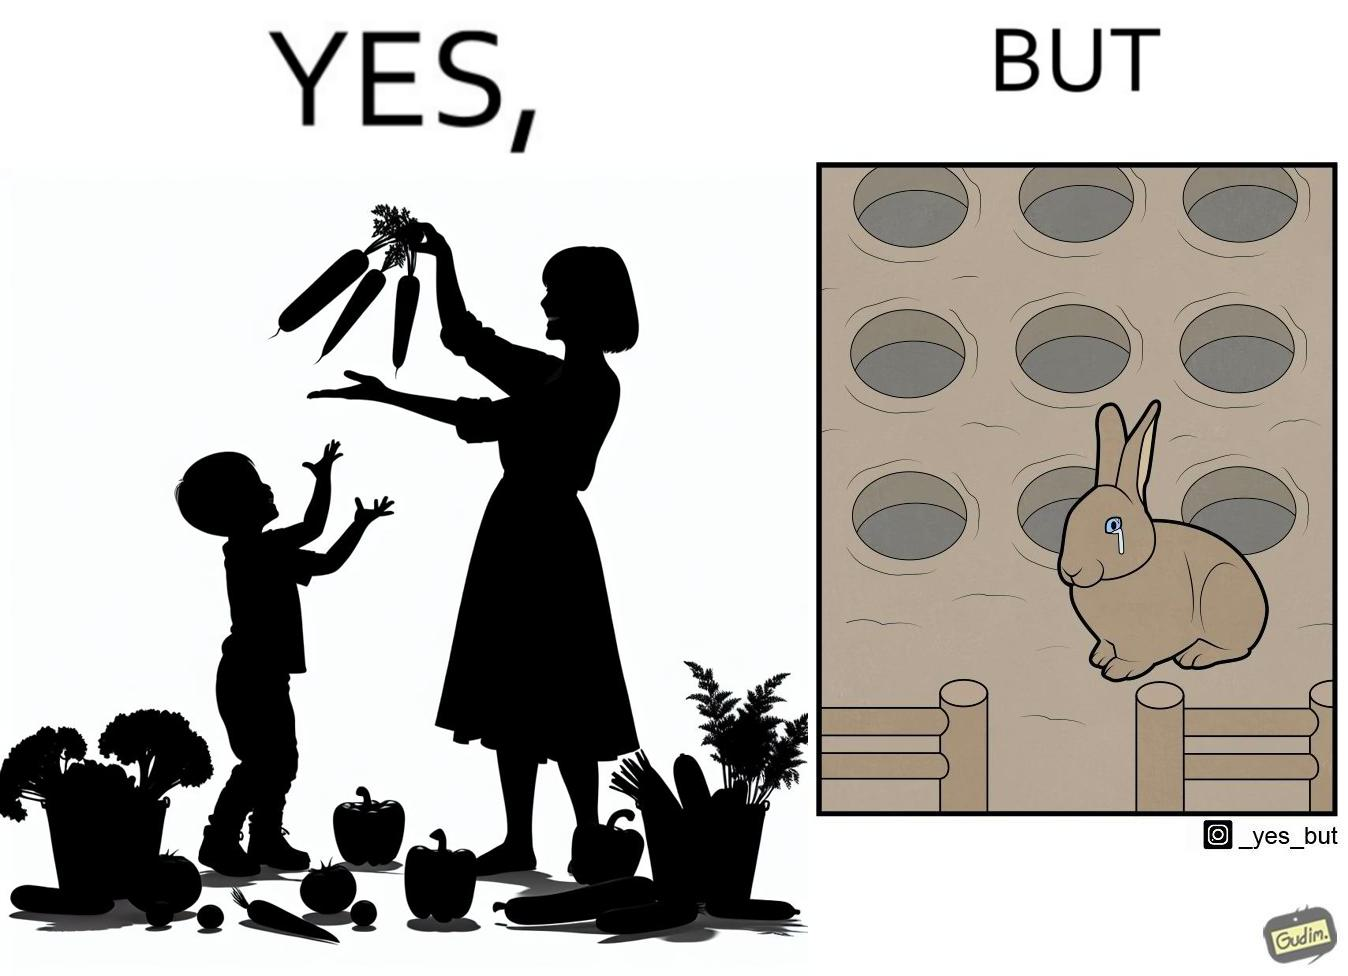Describe the content of this image. The images are ironic since they show how on one hand humans choose to play with and waste foods like vegetables while the animals are unable to eat enough food and end up starving due to lack of food 